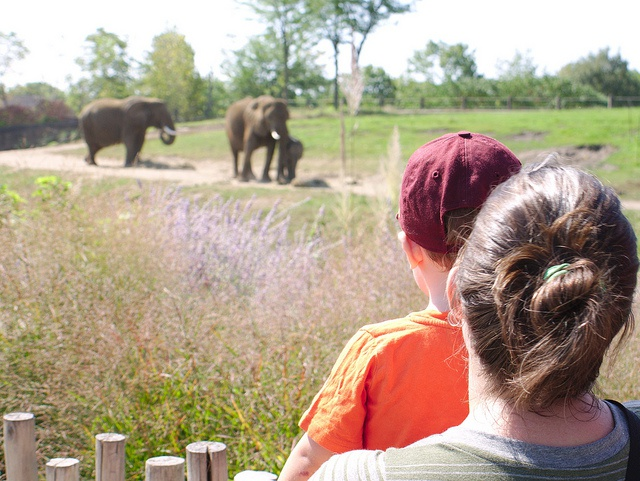Describe the objects in this image and their specific colors. I can see people in white, black, lightgray, gray, and maroon tones, people in white, red, lightpink, salmon, and maroon tones, elephant in white, gray, black, and darkgray tones, elephant in white, gray, tan, and black tones, and elephant in white, gray, and black tones in this image. 